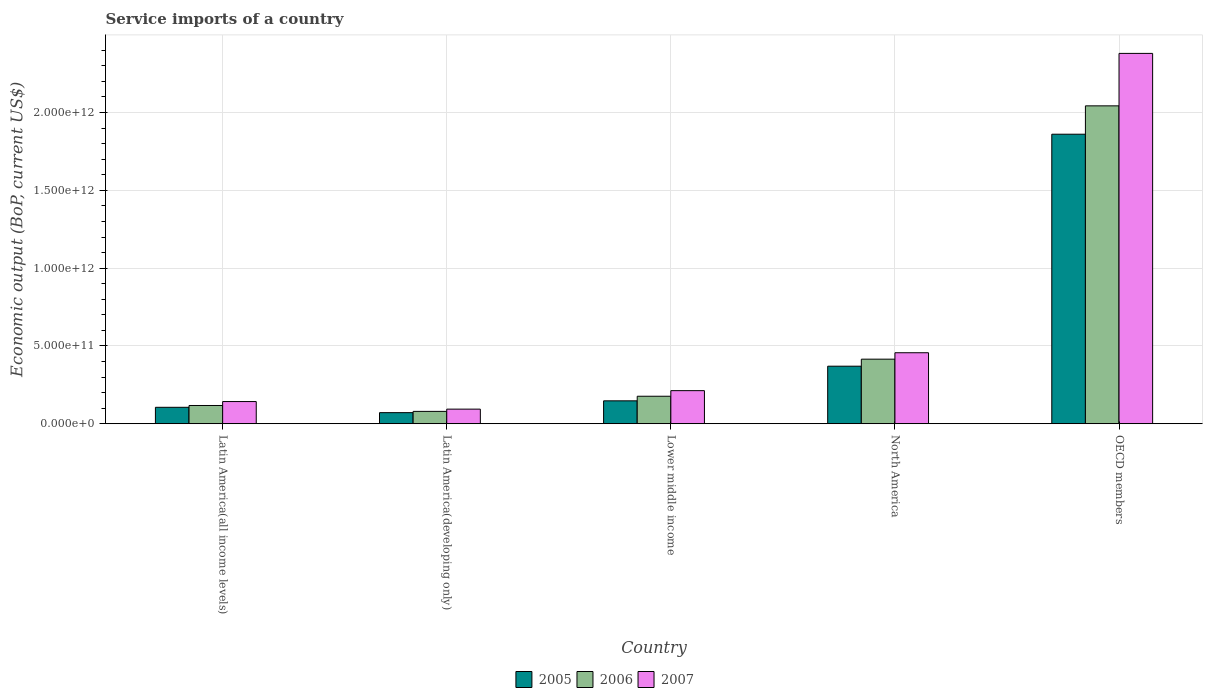How many groups of bars are there?
Your response must be concise. 5. Are the number of bars per tick equal to the number of legend labels?
Make the answer very short. Yes. How many bars are there on the 3rd tick from the left?
Your answer should be compact. 3. In how many cases, is the number of bars for a given country not equal to the number of legend labels?
Provide a succinct answer. 0. What is the service imports in 2005 in Lower middle income?
Your answer should be compact. 1.47e+11. Across all countries, what is the maximum service imports in 2005?
Your answer should be compact. 1.86e+12. Across all countries, what is the minimum service imports in 2006?
Offer a very short reply. 7.94e+1. In which country was the service imports in 2005 minimum?
Your answer should be very brief. Latin America(developing only). What is the total service imports in 2006 in the graph?
Give a very brief answer. 2.83e+12. What is the difference between the service imports in 2006 in Lower middle income and that in North America?
Your answer should be very brief. -2.38e+11. What is the difference between the service imports in 2007 in Latin America(all income levels) and the service imports in 2005 in OECD members?
Keep it short and to the point. -1.72e+12. What is the average service imports in 2005 per country?
Your answer should be very brief. 5.11e+11. What is the difference between the service imports of/in 2005 and service imports of/in 2007 in Lower middle income?
Offer a terse response. -6.55e+1. In how many countries, is the service imports in 2007 greater than 1400000000000 US$?
Provide a short and direct response. 1. What is the ratio of the service imports in 2005 in Latin America(all income levels) to that in Latin America(developing only)?
Keep it short and to the point. 1.48. Is the difference between the service imports in 2005 in Latin America(developing only) and OECD members greater than the difference between the service imports in 2007 in Latin America(developing only) and OECD members?
Offer a very short reply. Yes. What is the difference between the highest and the second highest service imports in 2006?
Give a very brief answer. 2.38e+11. What is the difference between the highest and the lowest service imports in 2007?
Keep it short and to the point. 2.29e+12. What does the 2nd bar from the left in Lower middle income represents?
Make the answer very short. 2006. Is it the case that in every country, the sum of the service imports in 2005 and service imports in 2007 is greater than the service imports in 2006?
Provide a short and direct response. Yes. How many bars are there?
Your answer should be compact. 15. What is the difference between two consecutive major ticks on the Y-axis?
Offer a very short reply. 5.00e+11. Where does the legend appear in the graph?
Make the answer very short. Bottom center. What is the title of the graph?
Your answer should be compact. Service imports of a country. Does "2007" appear as one of the legend labels in the graph?
Keep it short and to the point. Yes. What is the label or title of the X-axis?
Offer a terse response. Country. What is the label or title of the Y-axis?
Give a very brief answer. Economic output (BoP, current US$). What is the Economic output (BoP, current US$) in 2005 in Latin America(all income levels)?
Your answer should be very brief. 1.06e+11. What is the Economic output (BoP, current US$) in 2006 in Latin America(all income levels)?
Offer a very short reply. 1.17e+11. What is the Economic output (BoP, current US$) in 2007 in Latin America(all income levels)?
Ensure brevity in your answer.  1.43e+11. What is the Economic output (BoP, current US$) in 2005 in Latin America(developing only)?
Give a very brief answer. 7.13e+1. What is the Economic output (BoP, current US$) in 2006 in Latin America(developing only)?
Your answer should be compact. 7.94e+1. What is the Economic output (BoP, current US$) of 2007 in Latin America(developing only)?
Keep it short and to the point. 9.39e+1. What is the Economic output (BoP, current US$) of 2005 in Lower middle income?
Provide a succinct answer. 1.47e+11. What is the Economic output (BoP, current US$) of 2006 in Lower middle income?
Give a very brief answer. 1.77e+11. What is the Economic output (BoP, current US$) in 2007 in Lower middle income?
Ensure brevity in your answer.  2.13e+11. What is the Economic output (BoP, current US$) in 2005 in North America?
Make the answer very short. 3.70e+11. What is the Economic output (BoP, current US$) in 2006 in North America?
Ensure brevity in your answer.  4.15e+11. What is the Economic output (BoP, current US$) in 2007 in North America?
Give a very brief answer. 4.56e+11. What is the Economic output (BoP, current US$) of 2005 in OECD members?
Provide a succinct answer. 1.86e+12. What is the Economic output (BoP, current US$) of 2006 in OECD members?
Your answer should be compact. 2.04e+12. What is the Economic output (BoP, current US$) in 2007 in OECD members?
Ensure brevity in your answer.  2.38e+12. Across all countries, what is the maximum Economic output (BoP, current US$) in 2005?
Your answer should be compact. 1.86e+12. Across all countries, what is the maximum Economic output (BoP, current US$) in 2006?
Give a very brief answer. 2.04e+12. Across all countries, what is the maximum Economic output (BoP, current US$) of 2007?
Provide a succinct answer. 2.38e+12. Across all countries, what is the minimum Economic output (BoP, current US$) of 2005?
Ensure brevity in your answer.  7.13e+1. Across all countries, what is the minimum Economic output (BoP, current US$) in 2006?
Keep it short and to the point. 7.94e+1. Across all countries, what is the minimum Economic output (BoP, current US$) of 2007?
Keep it short and to the point. 9.39e+1. What is the total Economic output (BoP, current US$) in 2005 in the graph?
Your answer should be very brief. 2.55e+12. What is the total Economic output (BoP, current US$) of 2006 in the graph?
Give a very brief answer. 2.83e+12. What is the total Economic output (BoP, current US$) in 2007 in the graph?
Give a very brief answer. 3.29e+12. What is the difference between the Economic output (BoP, current US$) in 2005 in Latin America(all income levels) and that in Latin America(developing only)?
Your answer should be compact. 3.43e+1. What is the difference between the Economic output (BoP, current US$) of 2006 in Latin America(all income levels) and that in Latin America(developing only)?
Your answer should be compact. 3.79e+1. What is the difference between the Economic output (BoP, current US$) of 2007 in Latin America(all income levels) and that in Latin America(developing only)?
Ensure brevity in your answer.  4.87e+1. What is the difference between the Economic output (BoP, current US$) of 2005 in Latin America(all income levels) and that in Lower middle income?
Your response must be concise. -4.16e+1. What is the difference between the Economic output (BoP, current US$) in 2006 in Latin America(all income levels) and that in Lower middle income?
Your answer should be compact. -5.95e+1. What is the difference between the Economic output (BoP, current US$) in 2007 in Latin America(all income levels) and that in Lower middle income?
Your answer should be compact. -7.01e+1. What is the difference between the Economic output (BoP, current US$) of 2005 in Latin America(all income levels) and that in North America?
Offer a very short reply. -2.64e+11. What is the difference between the Economic output (BoP, current US$) of 2006 in Latin America(all income levels) and that in North America?
Provide a short and direct response. -2.98e+11. What is the difference between the Economic output (BoP, current US$) in 2007 in Latin America(all income levels) and that in North America?
Your answer should be compact. -3.14e+11. What is the difference between the Economic output (BoP, current US$) in 2005 in Latin America(all income levels) and that in OECD members?
Make the answer very short. -1.76e+12. What is the difference between the Economic output (BoP, current US$) of 2006 in Latin America(all income levels) and that in OECD members?
Your response must be concise. -1.93e+12. What is the difference between the Economic output (BoP, current US$) in 2007 in Latin America(all income levels) and that in OECD members?
Your answer should be compact. -2.24e+12. What is the difference between the Economic output (BoP, current US$) in 2005 in Latin America(developing only) and that in Lower middle income?
Give a very brief answer. -7.59e+1. What is the difference between the Economic output (BoP, current US$) of 2006 in Latin America(developing only) and that in Lower middle income?
Keep it short and to the point. -9.73e+1. What is the difference between the Economic output (BoP, current US$) of 2007 in Latin America(developing only) and that in Lower middle income?
Your response must be concise. -1.19e+11. What is the difference between the Economic output (BoP, current US$) of 2005 in Latin America(developing only) and that in North America?
Your answer should be compact. -2.99e+11. What is the difference between the Economic output (BoP, current US$) of 2006 in Latin America(developing only) and that in North America?
Offer a terse response. -3.36e+11. What is the difference between the Economic output (BoP, current US$) of 2007 in Latin America(developing only) and that in North America?
Ensure brevity in your answer.  -3.62e+11. What is the difference between the Economic output (BoP, current US$) of 2005 in Latin America(developing only) and that in OECD members?
Give a very brief answer. -1.79e+12. What is the difference between the Economic output (BoP, current US$) in 2006 in Latin America(developing only) and that in OECD members?
Make the answer very short. -1.96e+12. What is the difference between the Economic output (BoP, current US$) of 2007 in Latin America(developing only) and that in OECD members?
Ensure brevity in your answer.  -2.29e+12. What is the difference between the Economic output (BoP, current US$) of 2005 in Lower middle income and that in North America?
Ensure brevity in your answer.  -2.23e+11. What is the difference between the Economic output (BoP, current US$) of 2006 in Lower middle income and that in North America?
Offer a very short reply. -2.38e+11. What is the difference between the Economic output (BoP, current US$) of 2007 in Lower middle income and that in North America?
Offer a terse response. -2.44e+11. What is the difference between the Economic output (BoP, current US$) of 2005 in Lower middle income and that in OECD members?
Your answer should be compact. -1.71e+12. What is the difference between the Economic output (BoP, current US$) in 2006 in Lower middle income and that in OECD members?
Ensure brevity in your answer.  -1.87e+12. What is the difference between the Economic output (BoP, current US$) in 2007 in Lower middle income and that in OECD members?
Provide a succinct answer. -2.17e+12. What is the difference between the Economic output (BoP, current US$) in 2005 in North America and that in OECD members?
Keep it short and to the point. -1.49e+12. What is the difference between the Economic output (BoP, current US$) in 2006 in North America and that in OECD members?
Give a very brief answer. -1.63e+12. What is the difference between the Economic output (BoP, current US$) of 2007 in North America and that in OECD members?
Give a very brief answer. -1.92e+12. What is the difference between the Economic output (BoP, current US$) in 2005 in Latin America(all income levels) and the Economic output (BoP, current US$) in 2006 in Latin America(developing only)?
Provide a short and direct response. 2.62e+1. What is the difference between the Economic output (BoP, current US$) in 2005 in Latin America(all income levels) and the Economic output (BoP, current US$) in 2007 in Latin America(developing only)?
Your answer should be very brief. 1.17e+1. What is the difference between the Economic output (BoP, current US$) of 2006 in Latin America(all income levels) and the Economic output (BoP, current US$) of 2007 in Latin America(developing only)?
Your answer should be very brief. 2.34e+1. What is the difference between the Economic output (BoP, current US$) of 2005 in Latin America(all income levels) and the Economic output (BoP, current US$) of 2006 in Lower middle income?
Provide a succinct answer. -7.11e+1. What is the difference between the Economic output (BoP, current US$) in 2005 in Latin America(all income levels) and the Economic output (BoP, current US$) in 2007 in Lower middle income?
Provide a succinct answer. -1.07e+11. What is the difference between the Economic output (BoP, current US$) of 2006 in Latin America(all income levels) and the Economic output (BoP, current US$) of 2007 in Lower middle income?
Your answer should be compact. -9.54e+1. What is the difference between the Economic output (BoP, current US$) in 2005 in Latin America(all income levels) and the Economic output (BoP, current US$) in 2006 in North America?
Keep it short and to the point. -3.09e+11. What is the difference between the Economic output (BoP, current US$) in 2005 in Latin America(all income levels) and the Economic output (BoP, current US$) in 2007 in North America?
Offer a terse response. -3.51e+11. What is the difference between the Economic output (BoP, current US$) in 2006 in Latin America(all income levels) and the Economic output (BoP, current US$) in 2007 in North America?
Offer a terse response. -3.39e+11. What is the difference between the Economic output (BoP, current US$) of 2005 in Latin America(all income levels) and the Economic output (BoP, current US$) of 2006 in OECD members?
Your response must be concise. -1.94e+12. What is the difference between the Economic output (BoP, current US$) of 2005 in Latin America(all income levels) and the Economic output (BoP, current US$) of 2007 in OECD members?
Give a very brief answer. -2.27e+12. What is the difference between the Economic output (BoP, current US$) of 2006 in Latin America(all income levels) and the Economic output (BoP, current US$) of 2007 in OECD members?
Make the answer very short. -2.26e+12. What is the difference between the Economic output (BoP, current US$) in 2005 in Latin America(developing only) and the Economic output (BoP, current US$) in 2006 in Lower middle income?
Provide a short and direct response. -1.05e+11. What is the difference between the Economic output (BoP, current US$) in 2005 in Latin America(developing only) and the Economic output (BoP, current US$) in 2007 in Lower middle income?
Your answer should be compact. -1.41e+11. What is the difference between the Economic output (BoP, current US$) in 2006 in Latin America(developing only) and the Economic output (BoP, current US$) in 2007 in Lower middle income?
Keep it short and to the point. -1.33e+11. What is the difference between the Economic output (BoP, current US$) of 2005 in Latin America(developing only) and the Economic output (BoP, current US$) of 2006 in North America?
Give a very brief answer. -3.44e+11. What is the difference between the Economic output (BoP, current US$) in 2005 in Latin America(developing only) and the Economic output (BoP, current US$) in 2007 in North America?
Your answer should be compact. -3.85e+11. What is the difference between the Economic output (BoP, current US$) of 2006 in Latin America(developing only) and the Economic output (BoP, current US$) of 2007 in North America?
Provide a short and direct response. -3.77e+11. What is the difference between the Economic output (BoP, current US$) of 2005 in Latin America(developing only) and the Economic output (BoP, current US$) of 2006 in OECD members?
Provide a short and direct response. -1.97e+12. What is the difference between the Economic output (BoP, current US$) in 2005 in Latin America(developing only) and the Economic output (BoP, current US$) in 2007 in OECD members?
Your answer should be very brief. -2.31e+12. What is the difference between the Economic output (BoP, current US$) of 2006 in Latin America(developing only) and the Economic output (BoP, current US$) of 2007 in OECD members?
Your answer should be very brief. -2.30e+12. What is the difference between the Economic output (BoP, current US$) of 2005 in Lower middle income and the Economic output (BoP, current US$) of 2006 in North America?
Give a very brief answer. -2.68e+11. What is the difference between the Economic output (BoP, current US$) in 2005 in Lower middle income and the Economic output (BoP, current US$) in 2007 in North America?
Your response must be concise. -3.09e+11. What is the difference between the Economic output (BoP, current US$) in 2006 in Lower middle income and the Economic output (BoP, current US$) in 2007 in North America?
Offer a very short reply. -2.80e+11. What is the difference between the Economic output (BoP, current US$) in 2005 in Lower middle income and the Economic output (BoP, current US$) in 2006 in OECD members?
Ensure brevity in your answer.  -1.90e+12. What is the difference between the Economic output (BoP, current US$) of 2005 in Lower middle income and the Economic output (BoP, current US$) of 2007 in OECD members?
Keep it short and to the point. -2.23e+12. What is the difference between the Economic output (BoP, current US$) in 2006 in Lower middle income and the Economic output (BoP, current US$) in 2007 in OECD members?
Provide a short and direct response. -2.20e+12. What is the difference between the Economic output (BoP, current US$) in 2005 in North America and the Economic output (BoP, current US$) in 2006 in OECD members?
Offer a very short reply. -1.67e+12. What is the difference between the Economic output (BoP, current US$) of 2005 in North America and the Economic output (BoP, current US$) of 2007 in OECD members?
Ensure brevity in your answer.  -2.01e+12. What is the difference between the Economic output (BoP, current US$) in 2006 in North America and the Economic output (BoP, current US$) in 2007 in OECD members?
Provide a short and direct response. -1.97e+12. What is the average Economic output (BoP, current US$) of 2005 per country?
Give a very brief answer. 5.11e+11. What is the average Economic output (BoP, current US$) of 2006 per country?
Make the answer very short. 5.66e+11. What is the average Economic output (BoP, current US$) of 2007 per country?
Offer a terse response. 6.57e+11. What is the difference between the Economic output (BoP, current US$) of 2005 and Economic output (BoP, current US$) of 2006 in Latin America(all income levels)?
Offer a very short reply. -1.17e+1. What is the difference between the Economic output (BoP, current US$) of 2005 and Economic output (BoP, current US$) of 2007 in Latin America(all income levels)?
Your answer should be compact. -3.70e+1. What is the difference between the Economic output (BoP, current US$) in 2006 and Economic output (BoP, current US$) in 2007 in Latin America(all income levels)?
Provide a short and direct response. -2.53e+1. What is the difference between the Economic output (BoP, current US$) in 2005 and Economic output (BoP, current US$) in 2006 in Latin America(developing only)?
Ensure brevity in your answer.  -8.14e+09. What is the difference between the Economic output (BoP, current US$) in 2005 and Economic output (BoP, current US$) in 2007 in Latin America(developing only)?
Keep it short and to the point. -2.26e+1. What is the difference between the Economic output (BoP, current US$) of 2006 and Economic output (BoP, current US$) of 2007 in Latin America(developing only)?
Provide a short and direct response. -1.45e+1. What is the difference between the Economic output (BoP, current US$) in 2005 and Economic output (BoP, current US$) in 2006 in Lower middle income?
Your response must be concise. -2.95e+1. What is the difference between the Economic output (BoP, current US$) of 2005 and Economic output (BoP, current US$) of 2007 in Lower middle income?
Make the answer very short. -6.55e+1. What is the difference between the Economic output (BoP, current US$) in 2006 and Economic output (BoP, current US$) in 2007 in Lower middle income?
Offer a terse response. -3.59e+1. What is the difference between the Economic output (BoP, current US$) of 2005 and Economic output (BoP, current US$) of 2006 in North America?
Your answer should be compact. -4.52e+1. What is the difference between the Economic output (BoP, current US$) of 2005 and Economic output (BoP, current US$) of 2007 in North America?
Provide a short and direct response. -8.65e+1. What is the difference between the Economic output (BoP, current US$) of 2006 and Economic output (BoP, current US$) of 2007 in North America?
Make the answer very short. -4.13e+1. What is the difference between the Economic output (BoP, current US$) in 2005 and Economic output (BoP, current US$) in 2006 in OECD members?
Your answer should be compact. -1.82e+11. What is the difference between the Economic output (BoP, current US$) in 2005 and Economic output (BoP, current US$) in 2007 in OECD members?
Ensure brevity in your answer.  -5.19e+11. What is the difference between the Economic output (BoP, current US$) in 2006 and Economic output (BoP, current US$) in 2007 in OECD members?
Give a very brief answer. -3.37e+11. What is the ratio of the Economic output (BoP, current US$) of 2005 in Latin America(all income levels) to that in Latin America(developing only)?
Your answer should be compact. 1.48. What is the ratio of the Economic output (BoP, current US$) in 2006 in Latin America(all income levels) to that in Latin America(developing only)?
Your response must be concise. 1.48. What is the ratio of the Economic output (BoP, current US$) of 2007 in Latin America(all income levels) to that in Latin America(developing only)?
Provide a short and direct response. 1.52. What is the ratio of the Economic output (BoP, current US$) in 2005 in Latin America(all income levels) to that in Lower middle income?
Your answer should be very brief. 0.72. What is the ratio of the Economic output (BoP, current US$) of 2006 in Latin America(all income levels) to that in Lower middle income?
Provide a succinct answer. 0.66. What is the ratio of the Economic output (BoP, current US$) of 2007 in Latin America(all income levels) to that in Lower middle income?
Give a very brief answer. 0.67. What is the ratio of the Economic output (BoP, current US$) of 2005 in Latin America(all income levels) to that in North America?
Your response must be concise. 0.29. What is the ratio of the Economic output (BoP, current US$) in 2006 in Latin America(all income levels) to that in North America?
Your answer should be very brief. 0.28. What is the ratio of the Economic output (BoP, current US$) in 2007 in Latin America(all income levels) to that in North America?
Provide a succinct answer. 0.31. What is the ratio of the Economic output (BoP, current US$) in 2005 in Latin America(all income levels) to that in OECD members?
Offer a very short reply. 0.06. What is the ratio of the Economic output (BoP, current US$) of 2006 in Latin America(all income levels) to that in OECD members?
Offer a very short reply. 0.06. What is the ratio of the Economic output (BoP, current US$) in 2007 in Latin America(all income levels) to that in OECD members?
Keep it short and to the point. 0.06. What is the ratio of the Economic output (BoP, current US$) of 2005 in Latin America(developing only) to that in Lower middle income?
Make the answer very short. 0.48. What is the ratio of the Economic output (BoP, current US$) of 2006 in Latin America(developing only) to that in Lower middle income?
Ensure brevity in your answer.  0.45. What is the ratio of the Economic output (BoP, current US$) of 2007 in Latin America(developing only) to that in Lower middle income?
Provide a short and direct response. 0.44. What is the ratio of the Economic output (BoP, current US$) of 2005 in Latin America(developing only) to that in North America?
Make the answer very short. 0.19. What is the ratio of the Economic output (BoP, current US$) in 2006 in Latin America(developing only) to that in North America?
Offer a terse response. 0.19. What is the ratio of the Economic output (BoP, current US$) of 2007 in Latin America(developing only) to that in North America?
Offer a very short reply. 0.21. What is the ratio of the Economic output (BoP, current US$) of 2005 in Latin America(developing only) to that in OECD members?
Ensure brevity in your answer.  0.04. What is the ratio of the Economic output (BoP, current US$) of 2006 in Latin America(developing only) to that in OECD members?
Provide a short and direct response. 0.04. What is the ratio of the Economic output (BoP, current US$) in 2007 in Latin America(developing only) to that in OECD members?
Provide a short and direct response. 0.04. What is the ratio of the Economic output (BoP, current US$) of 2005 in Lower middle income to that in North America?
Provide a succinct answer. 0.4. What is the ratio of the Economic output (BoP, current US$) in 2006 in Lower middle income to that in North America?
Offer a very short reply. 0.43. What is the ratio of the Economic output (BoP, current US$) in 2007 in Lower middle income to that in North America?
Ensure brevity in your answer.  0.47. What is the ratio of the Economic output (BoP, current US$) in 2005 in Lower middle income to that in OECD members?
Offer a very short reply. 0.08. What is the ratio of the Economic output (BoP, current US$) of 2006 in Lower middle income to that in OECD members?
Your response must be concise. 0.09. What is the ratio of the Economic output (BoP, current US$) in 2007 in Lower middle income to that in OECD members?
Offer a terse response. 0.09. What is the ratio of the Economic output (BoP, current US$) in 2005 in North America to that in OECD members?
Make the answer very short. 0.2. What is the ratio of the Economic output (BoP, current US$) in 2006 in North America to that in OECD members?
Provide a succinct answer. 0.2. What is the ratio of the Economic output (BoP, current US$) in 2007 in North America to that in OECD members?
Your response must be concise. 0.19. What is the difference between the highest and the second highest Economic output (BoP, current US$) in 2005?
Your answer should be very brief. 1.49e+12. What is the difference between the highest and the second highest Economic output (BoP, current US$) of 2006?
Your response must be concise. 1.63e+12. What is the difference between the highest and the second highest Economic output (BoP, current US$) in 2007?
Give a very brief answer. 1.92e+12. What is the difference between the highest and the lowest Economic output (BoP, current US$) in 2005?
Provide a short and direct response. 1.79e+12. What is the difference between the highest and the lowest Economic output (BoP, current US$) in 2006?
Your response must be concise. 1.96e+12. What is the difference between the highest and the lowest Economic output (BoP, current US$) in 2007?
Make the answer very short. 2.29e+12. 